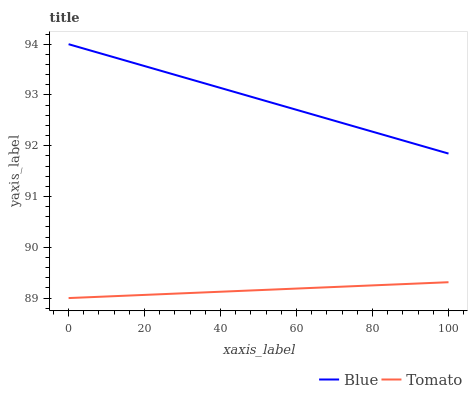Does Tomato have the minimum area under the curve?
Answer yes or no. Yes. Does Blue have the maximum area under the curve?
Answer yes or no. Yes. Does Tomato have the maximum area under the curve?
Answer yes or no. No. Is Blue the smoothest?
Answer yes or no. Yes. Is Tomato the roughest?
Answer yes or no. Yes. Is Tomato the smoothest?
Answer yes or no. No. Does Tomato have the lowest value?
Answer yes or no. Yes. Does Blue have the highest value?
Answer yes or no. Yes. Does Tomato have the highest value?
Answer yes or no. No. Is Tomato less than Blue?
Answer yes or no. Yes. Is Blue greater than Tomato?
Answer yes or no. Yes. Does Tomato intersect Blue?
Answer yes or no. No. 